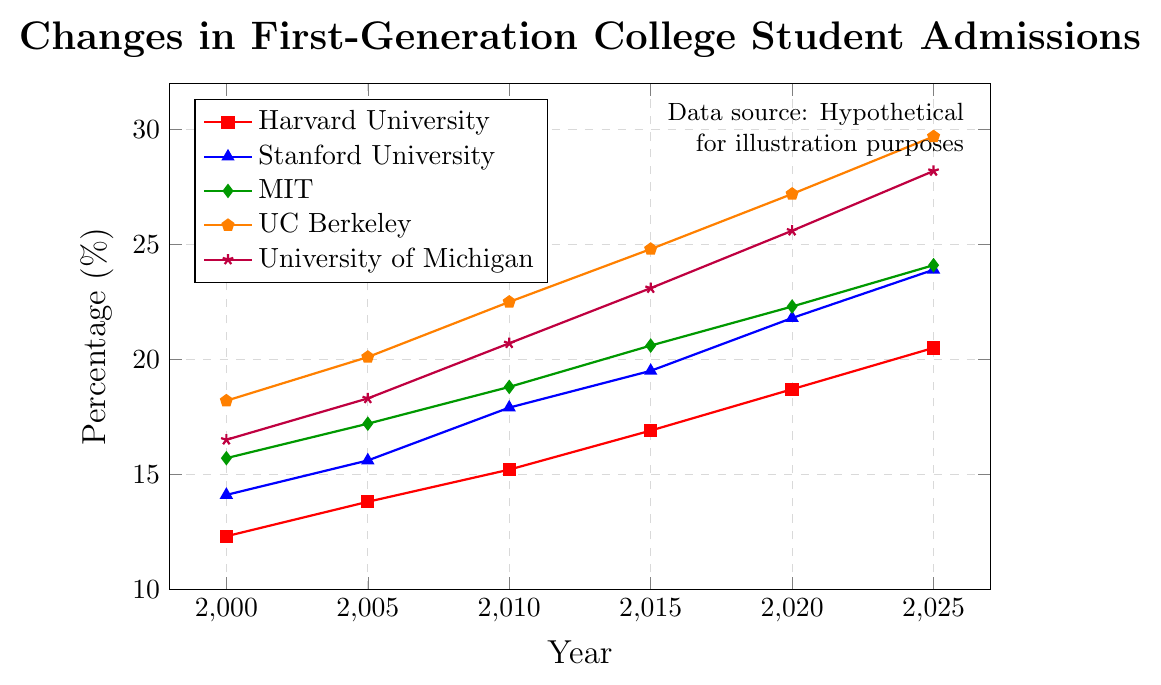What is the percentage increase in first-generation college students at Harvard University from 2000 to 2025? From the figure, the percentage of first-generation students at Harvard University is 12.3% in 2000 and 20.5% in 2025. To find the percentage increase, subtract the 2000 value from the 2025 value and then divide by the 2000 value. Finally, multiply by 100 to get the percentage: [(20.5 - 12.3) / 12.3] * 100.
Answer: 66.67% Which university had the highest percentage of first-generation college students admitted in 2015? By observing the figure for the year 2015, we compare the percentages for each university: Harvard University (16.9%), Stanford University (19.5%), MIT (20.6%), UC Berkeley (24.8%), and University of Michigan (23.1%). The highest value is 24.8% at UC Berkeley.
Answer: UC Berkeley Between UC Berkeley and University of Michigan, which university saw a larger absolute increase in the percentage of first-generation college students from 2000 to 2025? From the figure, UC Berkeley's percentage in 2000 is 18.2% and in 2025 is 29.7%, giving an increase of 29.7 - 18.2 = 11.5%. For University of Michigan, the percentage in 2000 is 16.5% and in 2025 is 28.2%, resulting in an increase of 28.2 - 16.5 = 11.7%. University of Michigan saw a larger increase.
Answer: University of Michigan What is the average percentage of first-generation college students admitted to MIT across all the years shown (2000, 2005, 2010, 2015, 2020, 2025)? The percentages for MIT from the figure are 15.7%, 17.2%, 18.8%, 20.6%, 22.3%, and 24.1%. To find the average, we sum these values and divide by the number of data points: (15.7 + 17.2 + 18.8 + 20.6 + 22.3 + 24.1) / 6.
Answer: 19.78% Between 2000 and 2025, which university demonstrates the most consistent growth in the percentage of first-generation student admissions? To determine consistency, we observe the trends in the figure. UC Berkeley and University of Michigan both show steadily increasing lines, but UC Berkeley's increases at a slightly higher and more consistent rate each interval compared to the other universities.
Answer: UC Berkeley By what percentage did the first-generation college student admissions rate at Stanford University increase from 2010 to 2025? From the figure, the percentage at Stanford University is 17.9% in 2010 and 23.9% in 2025. To find the percentage increase, calculate [(23.9 - 17.9) / 17.9] * 100.
Answer: 33.52% 